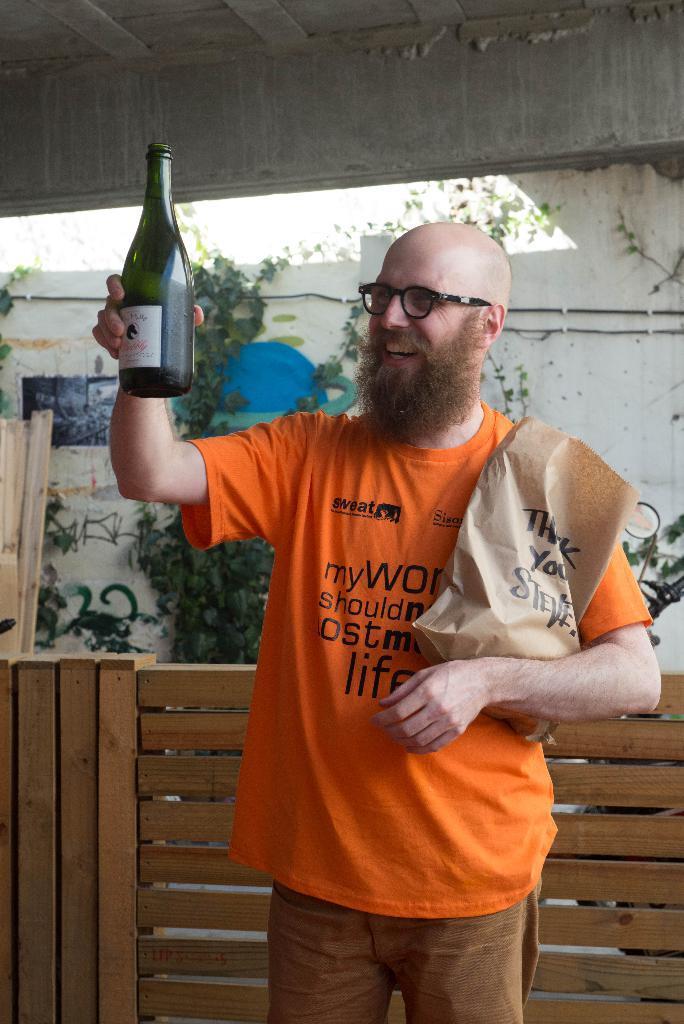Can you describe this image briefly? There is a man standing in this picture. He is wearing a brown trousers and orange T-shirt and there is some text written on his T-shirt. He is holding a champagne bottle in his right hand and a paper bag in his left arm. He has long beard and wearing spectacles. He is looking at the bottle and smiling. Behind him there is wooden railing and wall. On the wall there are cables and creepers. 